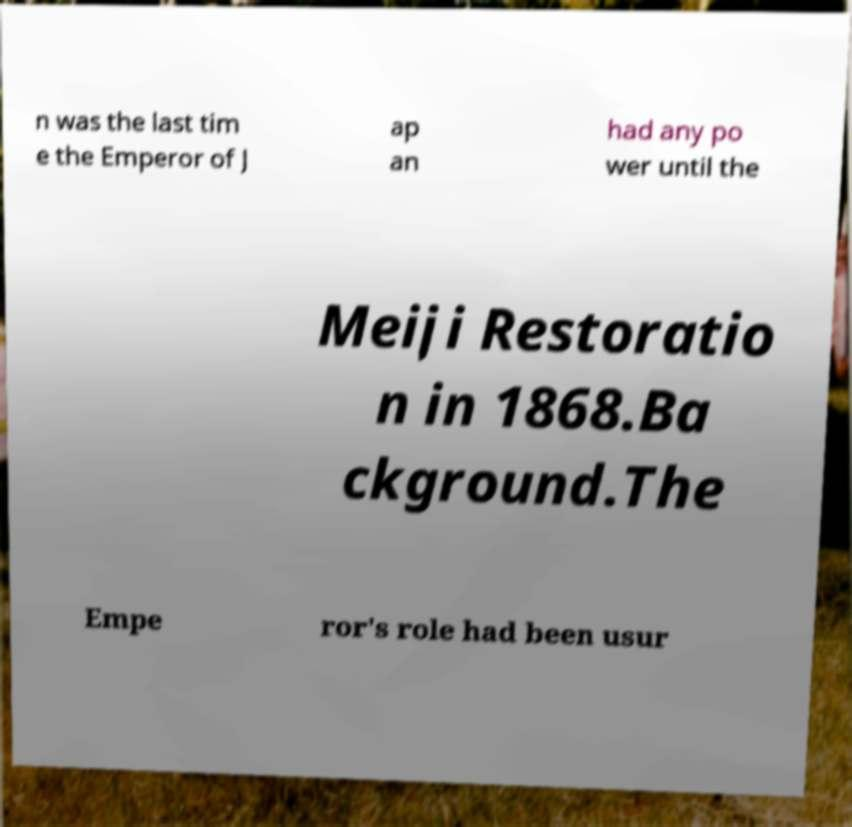I need the written content from this picture converted into text. Can you do that? n was the last tim e the Emperor of J ap an had any po wer until the Meiji Restoratio n in 1868.Ba ckground.The Empe ror's role had been usur 